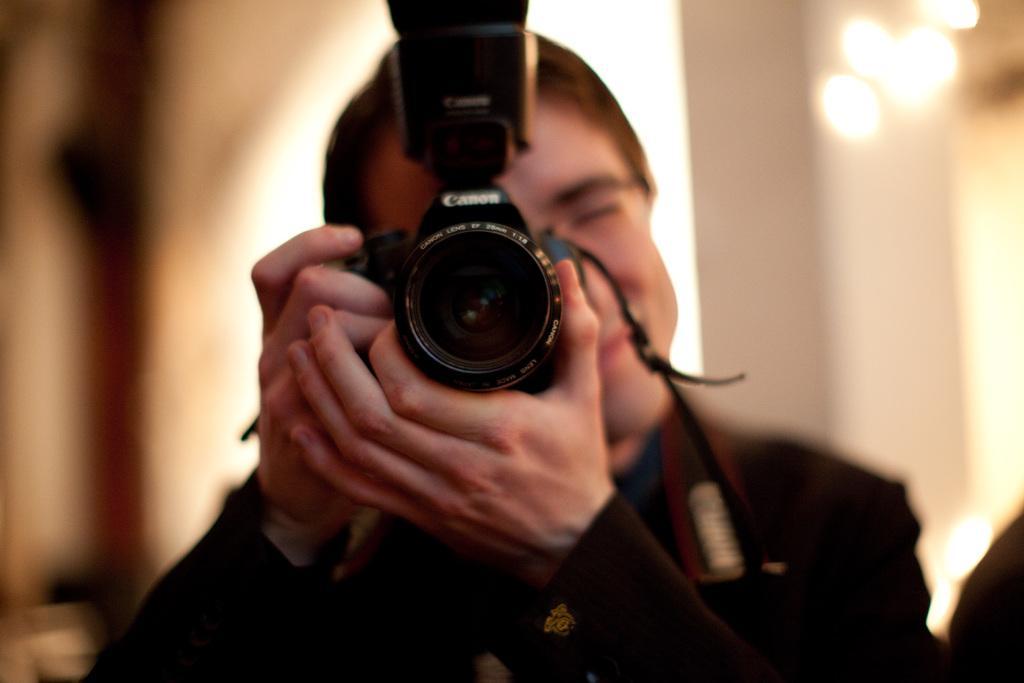Describe this image in one or two sentences. In this picture there is a man at the center of the image by holding a camera in his hands and there are lights at the right side of the image, it seems to be he is taking a photo. 